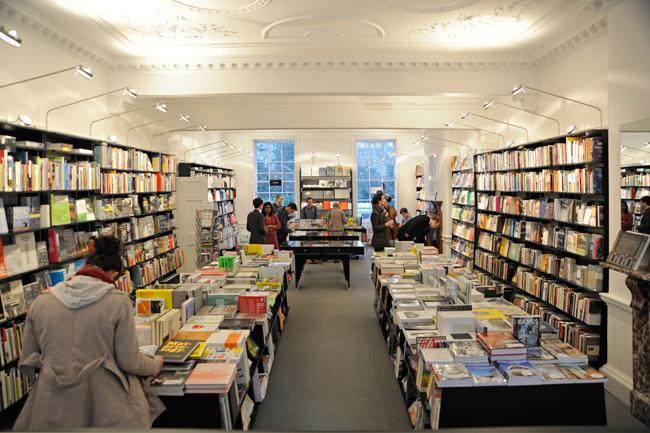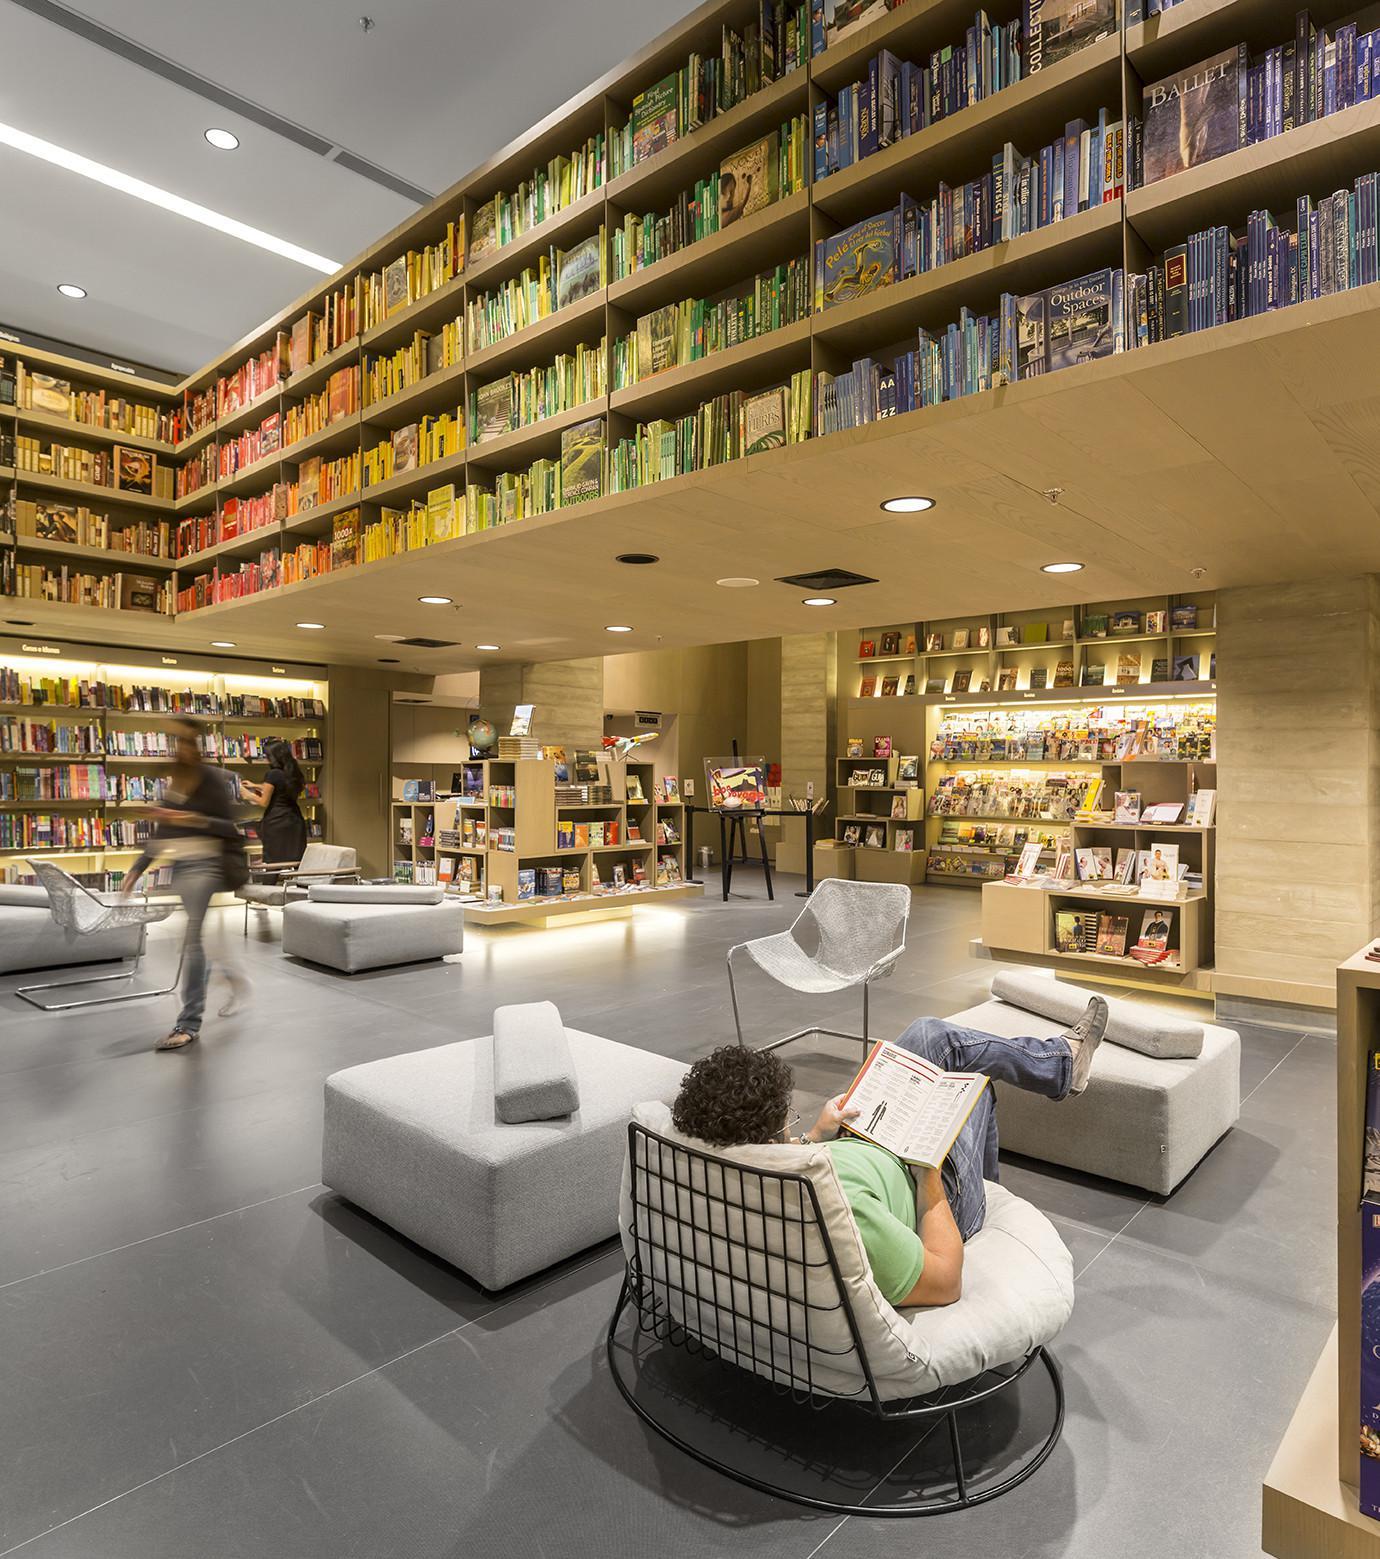The first image is the image on the left, the second image is the image on the right. Given the left and right images, does the statement "In one image, four rows of books are on shelves high over the heads of people on the floor below." hold true? Answer yes or no. Yes. The first image is the image on the left, the second image is the image on the right. Analyze the images presented: Is the assertion "In one of the images there is a bookstore without any shoppers." valid? Answer yes or no. No. 